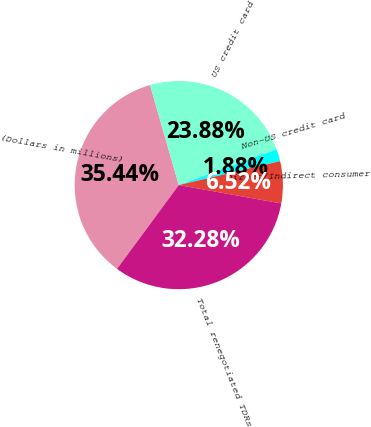<chart> <loc_0><loc_0><loc_500><loc_500><pie_chart><fcel>(Dollars in millions)<fcel>US credit card<fcel>Non-US credit card<fcel>Direct/Indirect consumer<fcel>Total renegotiated TDRs<nl><fcel>35.44%<fcel>23.88%<fcel>1.88%<fcel>6.52%<fcel>32.28%<nl></chart> 